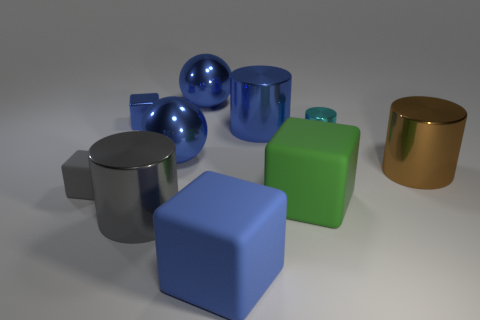Subtract all small cyan metal cylinders. How many cylinders are left? 3 Subtract all brown cylinders. How many blue cubes are left? 2 Subtract all blue blocks. How many blocks are left? 2 Subtract all cubes. How many objects are left? 6 Subtract 3 cylinders. How many cylinders are left? 1 Add 5 small cyan cylinders. How many small cyan cylinders are left? 6 Add 4 large metal balls. How many large metal balls exist? 6 Subtract 0 green balls. How many objects are left? 10 Subtract all yellow cylinders. Subtract all green spheres. How many cylinders are left? 4 Subtract all large cylinders. Subtract all gray cubes. How many objects are left? 6 